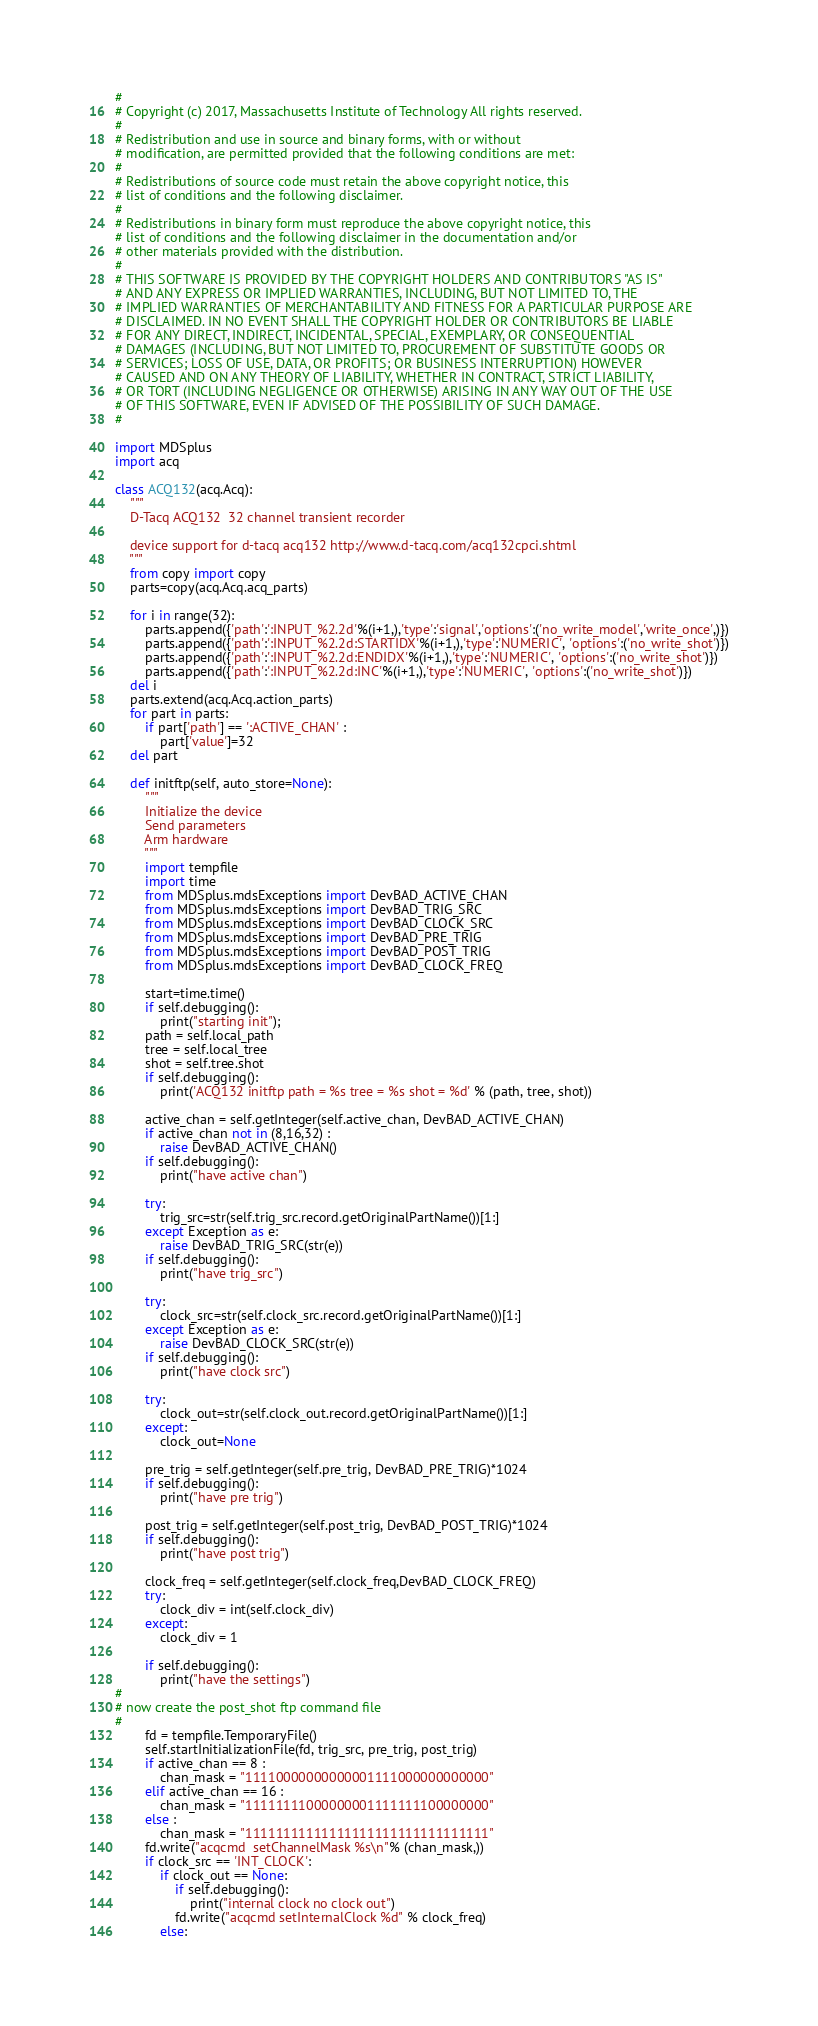Convert code to text. <code><loc_0><loc_0><loc_500><loc_500><_Python_>#
# Copyright (c) 2017, Massachusetts Institute of Technology All rights reserved.
#
# Redistribution and use in source and binary forms, with or without
# modification, are permitted provided that the following conditions are met:
#
# Redistributions of source code must retain the above copyright notice, this
# list of conditions and the following disclaimer.
#
# Redistributions in binary form must reproduce the above copyright notice, this
# list of conditions and the following disclaimer in the documentation and/or
# other materials provided with the distribution.
#
# THIS SOFTWARE IS PROVIDED BY THE COPYRIGHT HOLDERS AND CONTRIBUTORS "AS IS"
# AND ANY EXPRESS OR IMPLIED WARRANTIES, INCLUDING, BUT NOT LIMITED TO, THE
# IMPLIED WARRANTIES OF MERCHANTABILITY AND FITNESS FOR A PARTICULAR PURPOSE ARE
# DISCLAIMED. IN NO EVENT SHALL THE COPYRIGHT HOLDER OR CONTRIBUTORS BE LIABLE
# FOR ANY DIRECT, INDIRECT, INCIDENTAL, SPECIAL, EXEMPLARY, OR CONSEQUENTIAL
# DAMAGES (INCLUDING, BUT NOT LIMITED TO, PROCUREMENT OF SUBSTITUTE GOODS OR
# SERVICES; LOSS OF USE, DATA, OR PROFITS; OR BUSINESS INTERRUPTION) HOWEVER
# CAUSED AND ON ANY THEORY OF LIABILITY, WHETHER IN CONTRACT, STRICT LIABILITY,
# OR TORT (INCLUDING NEGLIGENCE OR OTHERWISE) ARISING IN ANY WAY OUT OF THE USE
# OF THIS SOFTWARE, EVEN IF ADVISED OF THE POSSIBILITY OF SUCH DAMAGE.
#

import MDSplus
import acq

class ACQ132(acq.Acq):
    """
    D-Tacq ACQ132  32 channel transient recorder

    device support for d-tacq acq132 http://www.d-tacq.com/acq132cpci.shtml
    """
    from copy import copy
    parts=copy(acq.Acq.acq_parts)

    for i in range(32):
        parts.append({'path':':INPUT_%2.2d'%(i+1,),'type':'signal','options':('no_write_model','write_once',)})
        parts.append({'path':':INPUT_%2.2d:STARTIDX'%(i+1,),'type':'NUMERIC', 'options':('no_write_shot')})
        parts.append({'path':':INPUT_%2.2d:ENDIDX'%(i+1,),'type':'NUMERIC', 'options':('no_write_shot')})
        parts.append({'path':':INPUT_%2.2d:INC'%(i+1,),'type':'NUMERIC', 'options':('no_write_shot')})
    del i
    parts.extend(acq.Acq.action_parts)
    for part in parts:
        if part['path'] == ':ACTIVE_CHAN' :
            part['value']=32
    del part

    def initftp(self, auto_store=None):
        """
        Initialize the device
        Send parameters
        Arm hardware
        """
        import tempfile
        import time
        from MDSplus.mdsExceptions import DevBAD_ACTIVE_CHAN
        from MDSplus.mdsExceptions import DevBAD_TRIG_SRC
        from MDSplus.mdsExceptions import DevBAD_CLOCK_SRC
        from MDSplus.mdsExceptions import DevBAD_PRE_TRIG
        from MDSplus.mdsExceptions import DevBAD_POST_TRIG
        from MDSplus.mdsExceptions import DevBAD_CLOCK_FREQ

        start=time.time()
        if self.debugging():
            print("starting init");
        path = self.local_path
        tree = self.local_tree
        shot = self.tree.shot
        if self.debugging():
            print('ACQ132 initftp path = %s tree = %s shot = %d' % (path, tree, shot))

        active_chan = self.getInteger(self.active_chan, DevBAD_ACTIVE_CHAN)
        if active_chan not in (8,16,32) :
            raise DevBAD_ACTIVE_CHAN()
        if self.debugging():
            print("have active chan")

        try:
            trig_src=str(self.trig_src.record.getOriginalPartName())[1:]
        except Exception as e:
            raise DevBAD_TRIG_SRC(str(e))
        if self.debugging():
            print("have trig_src")

        try:
            clock_src=str(self.clock_src.record.getOriginalPartName())[1:]
        except Exception as e:
            raise DevBAD_CLOCK_SRC(str(e))
        if self.debugging():
            print("have clock src")

        try:
            clock_out=str(self.clock_out.record.getOriginalPartName())[1:]
        except:
            clock_out=None

        pre_trig = self.getInteger(self.pre_trig, DevBAD_PRE_TRIG)*1024
        if self.debugging():
            print("have pre trig")

        post_trig = self.getInteger(self.post_trig, DevBAD_POST_TRIG)*1024
        if self.debugging():
            print("have post trig")

        clock_freq = self.getInteger(self.clock_freq,DevBAD_CLOCK_FREQ)
        try:
            clock_div = int(self.clock_div)
        except:
            clock_div = 1

        if self.debugging():
            print("have the settings")
#
# now create the post_shot ftp command file
#
        fd = tempfile.TemporaryFile()
        self.startInitializationFile(fd, trig_src, pre_trig, post_trig)
        if active_chan == 8 :
            chan_mask = "11110000000000001111000000000000"
        elif active_chan == 16 :
            chan_mask = "11111111000000001111111100000000"
        else :
            chan_mask = "11111111111111111111111111111111"
        fd.write("acqcmd  setChannelMask %s\n"% (chan_mask,))
        if clock_src == 'INT_CLOCK':
            if clock_out == None:
                if self.debugging():
                    print("internal clock no clock out")
                fd.write("acqcmd setInternalClock %d" % clock_freq)
            else:</code> 